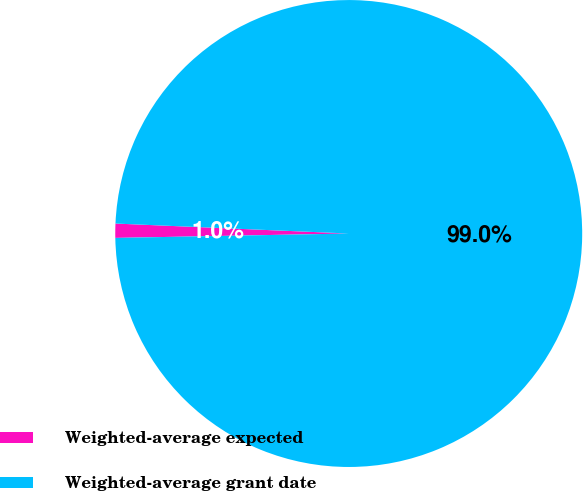Convert chart. <chart><loc_0><loc_0><loc_500><loc_500><pie_chart><fcel>Weighted-average expected<fcel>Weighted-average grant date<nl><fcel>0.98%<fcel>99.02%<nl></chart> 